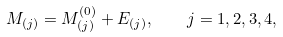<formula> <loc_0><loc_0><loc_500><loc_500>M _ { ( j ) } = M _ { ( j ) } ^ { ( 0 ) } + E _ { ( j ) } , \quad j = 1 , 2 , 3 , 4 ,</formula> 